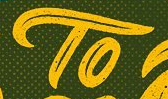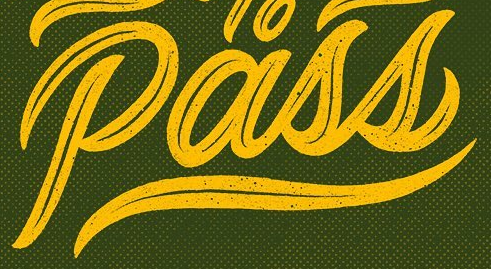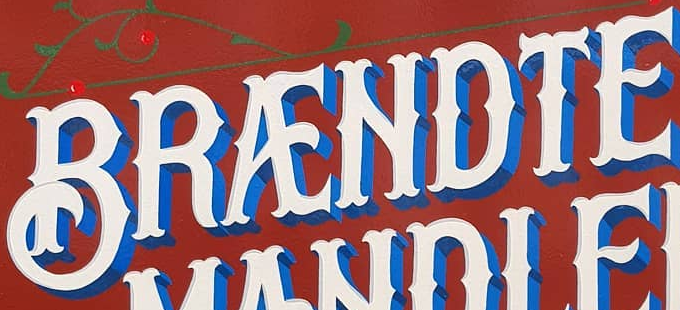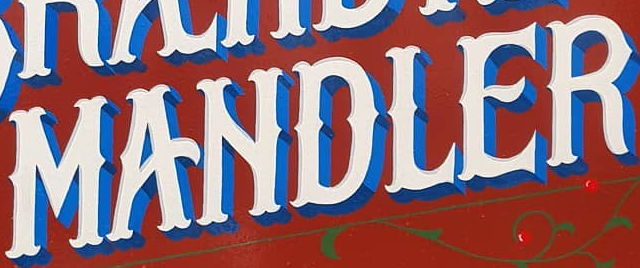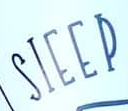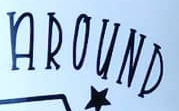Identify the words shown in these images in order, separated by a semicolon. TO; Pass; BRÆNDTE; MANDLER; SIEEP; AROUND 